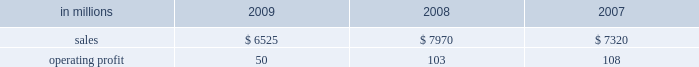Higher in the first half of the year , but declined dur- ing the second half of the year reflecting the pass- through to customers of lower resin input costs .
However , average margins benefitted from a more favorable mix of products sold .
Raw material costs were lower , primarily for resins .
Freight costs were also favorable , while operating costs increased .
Shorewood sales volumes in 2009 declined from 2008 levels reflecting weaker demand in the home entertainment segment and a decrease in tobacco segment orders as customers have shifted pro- duction outside of the united states , partially offset by higher shipments in the consumer products segment .
Average sales margins improved reflecting a more favorable mix of products sold .
Raw material costs were higher , but were partially offset by lower freight costs .
Operating costs were favorable , reflect- ing benefits from business reorganization and cost reduction actions taken in 2008 and 2009 .
Charges to restructure operations totaled $ 7 million in 2009 and $ 30 million in 2008 .
Entering 2010 , coated paperboard sales volumes are expected to increase , while average sales price real- izations should be comparable to 2009 fourth-quarter levels .
Raw material costs are expected to be sig- nificantly higher for wood , energy and chemicals , but planned maintenance downtime costs will decrease .
Foodservice sales volumes are expected to remain about flat , but average sales price realizations should improve slightly .
Input costs for resins should be higher , but will be partially offset by lower costs for bleached board .
Shorewood sales volumes are expected to decline reflecting seasonal decreases in home entertainment segment shipments .
Operating costs are expected to be favorable reflecting the benefits of business reorganization efforts .
European consumer packaging net sales in 2009 were $ 315 million compared with $ 300 million in 2008 and $ 280 million in 2007 .
Operating earnings in 2009 of $ 66 million increased from $ 22 million in 2008 and $ 30 million in 2007 .
Sales volumes in 2009 were higher than in 2008 reflecting increased ship- ments to export markets .
Average sales margins declined due to increased shipments to lower- margin export markets and lower average sales prices in western europe .
Entering 2010 , sales volumes for the first quarter are expected to remain strong .
Average margins should improve reflecting increased sales price realizations and a more favorable geographic mix of products sold .
Input costs are expected to be higher due to increased wood prices in poland and annual energy tariff increases in russia .
Asian consumer packaging net sales were $ 545 million in 2009 compared with $ 390 million in 2008 and $ 330 million in 2007 .
Operating earnings in 2009 were $ 24 million compared with a loss of $ 13 million in 2008 and earnings of $ 12 million in 2007 .
The improved operating earnings in 2009 reflect increased sales volumes , higher average sales mar- gins and lower input costs , primarily for chemicals .
The loss in 2008 was primarily due to a $ 12 million charge to revalue pulp inventories at our shandong international paper and sun coated paperboard co. , ltd .
Joint venture and start-up costs associated with the joint venture 2019s new folding box board paper machine .
Distribution xpedx , our distribution business , markets a diverse array of products and supply chain services to cus- tomers in many business segments .
Customer demand is generally sensitive to changes in general economic conditions , although the commercial printing segment is also dependent on consumer advertising and promotional spending .
Distribution 2019s margins are relatively stable across an economic cycle .
Providing customers with the best choice and value in both products and supply chain services is a key competitive factor .
Additionally , efficient customer service , cost-effective logistics and focused working capital management are key factors in this segment 2019s profitability .
Distribution in millions 2009 2008 2007 .
Distribution 2019s 2009 annual sales decreased 18% ( 18 % ) from 2008 and 11% ( 11 % ) from 2007 while operating profits in 2009 decreased 51% ( 51 % ) compared with 2008 and 54% ( 54 % ) compared with 2007 .
Annual sales of printing papers and graphic arts supplies and equipment totaled $ 4.1 billion in 2009 compared with $ 5.2 billion in 2008 and $ 4.7 billion in 2007 , reflecting weak economic conditions in 2009 .
Trade margins as a percent of sales for printing papers increased from 2008 but decreased from 2007 due to a higher mix of lower margin direct ship- ments from manufacturers .
Revenue from packaging products was $ 1.3 billion in 2009 compared with $ 1.7 billion in 2008 and $ 1.5 billion in 2007 .
Trade margins as a percent of sales for packaging products were higher than in the past two years reflecting an improved product and service mix .
Facility supplies annual revenue was $ 1.1 billion in 2009 , essentially .
What is the difference between the highest and average value of operating profit? 
Rationale: it is the variation between the maximum and average values .
Computations: subtract(table_max(operating profit, none), table_average(operating profit, none))
Answer: 21.0. 